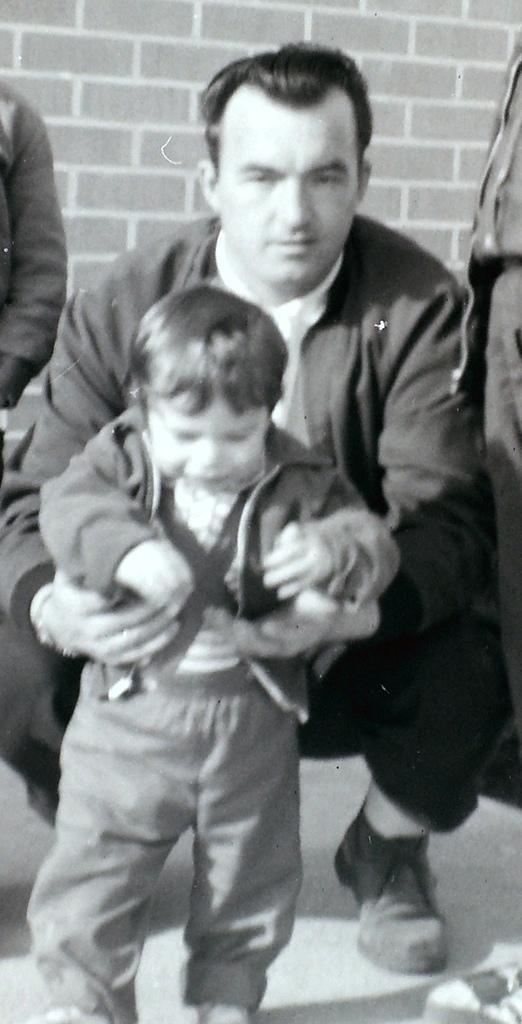Please provide a concise description of this image. In this picture we can see a man wearing black suit and holding the small boy. Behind we can see the brick texture wall. 